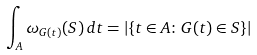Convert formula to latex. <formula><loc_0><loc_0><loc_500><loc_500>\int _ { A } \omega _ { G ( t ) } ( S ) \, d t = \left | \{ t \in A \colon G ( t ) \in S \} \right |</formula> 